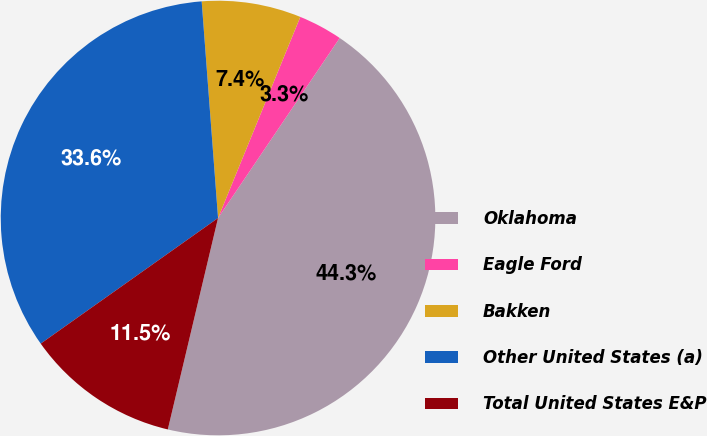<chart> <loc_0><loc_0><loc_500><loc_500><pie_chart><fcel>Oklahoma<fcel>Eagle Ford<fcel>Bakken<fcel>Other United States (a)<fcel>Total United States E&P<nl><fcel>44.26%<fcel>3.28%<fcel>7.38%<fcel>33.61%<fcel>11.48%<nl></chart> 